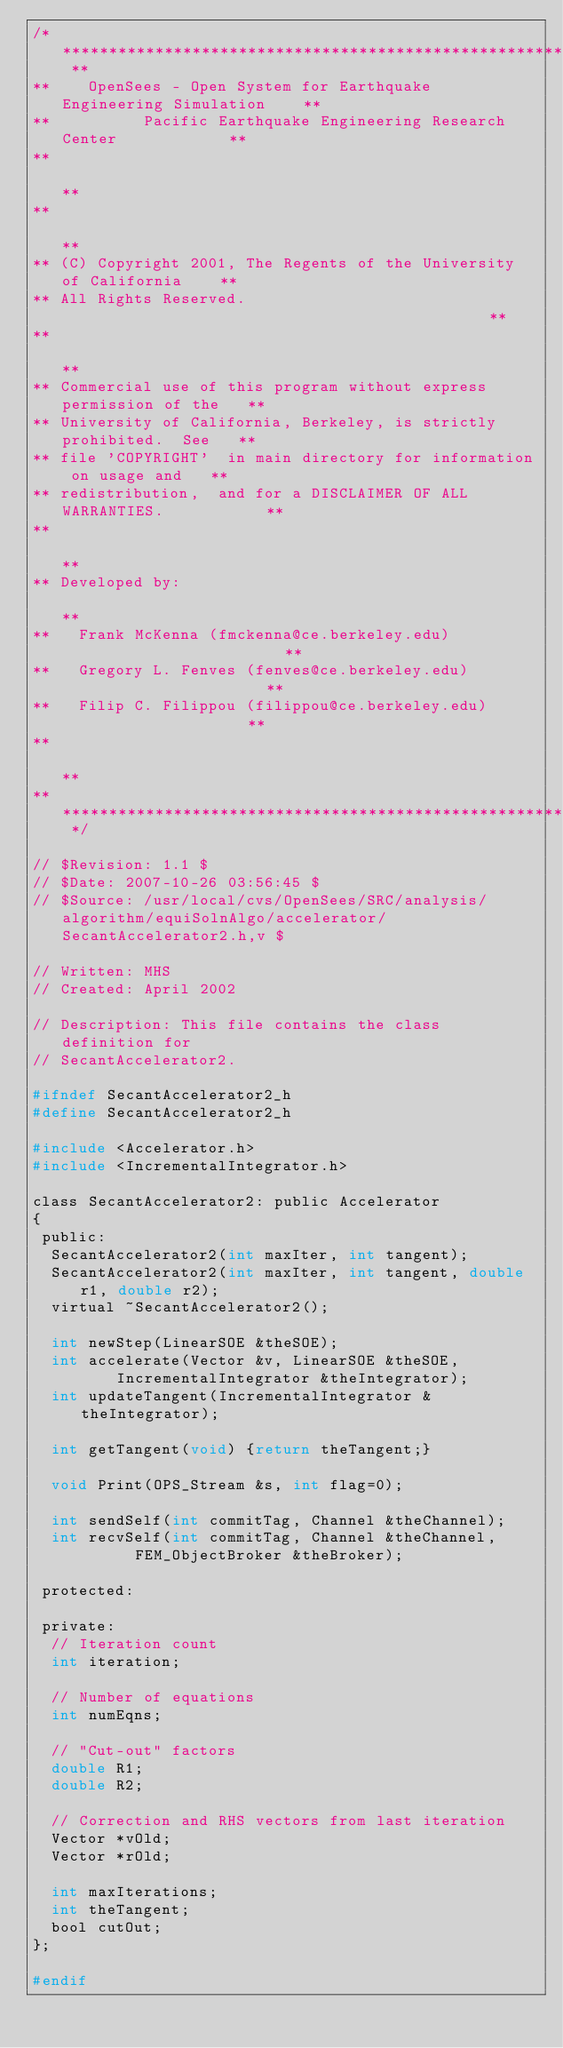Convert code to text. <code><loc_0><loc_0><loc_500><loc_500><_C_>/* ****************************************************************** **
**    OpenSees - Open System for Earthquake Engineering Simulation    **
**          Pacific Earthquake Engineering Research Center            **
**                                                                    **
**                                                                    **
** (C) Copyright 2001, The Regents of the University of California    **
** All Rights Reserved.                                               **
**                                                                    **
** Commercial use of this program without express permission of the   **
** University of California, Berkeley, is strictly prohibited.  See   **
** file 'COPYRIGHT'  in main directory for information on usage and   **
** redistribution,  and for a DISCLAIMER OF ALL WARRANTIES.           **
**                                                                    **
** Developed by:                                                      **
**   Frank McKenna (fmckenna@ce.berkeley.edu)                         **
**   Gregory L. Fenves (fenves@ce.berkeley.edu)                       **
**   Filip C. Filippou (filippou@ce.berkeley.edu)                     **
**                                                                    **
** ****************************************************************** */

// $Revision: 1.1 $
// $Date: 2007-10-26 03:56:45 $
// $Source: /usr/local/cvs/OpenSees/SRC/analysis/algorithm/equiSolnAlgo/accelerator/SecantAccelerator2.h,v $

// Written: MHS
// Created: April 2002

// Description: This file contains the class definition for 
// SecantAccelerator2. 

#ifndef SecantAccelerator2_h
#define SecantAccelerator2_h

#include <Accelerator.h>
#include <IncrementalIntegrator.h>

class SecantAccelerator2: public Accelerator
{
 public:
  SecantAccelerator2(int maxIter, int tangent);
  SecantAccelerator2(int maxIter, int tangent, double r1, double r2);
  virtual ~SecantAccelerator2();
  
  int newStep(LinearSOE &theSOE);
  int accelerate(Vector &v, LinearSOE &theSOE, 
		 IncrementalIntegrator &theIntegrator);
  int updateTangent(IncrementalIntegrator &theIntegrator);
  
  int getTangent(void) {return theTangent;}

  void Print(OPS_Stream &s, int flag=0);
  
  int sendSelf(int commitTag, Channel &theChannel);
  int recvSelf(int commitTag, Channel &theChannel, 
	       FEM_ObjectBroker &theBroker);
  
 protected:
  
 private:
  // Iteration count
  int iteration;
  
  // Number of equations
  int numEqns;
  
  // "Cut-out" factors
  double R1;
  double R2;
  
  // Correction and RHS vectors from last iteration
  Vector *vOld;
  Vector *rOld;
  
  int maxIterations;
  int theTangent;
  bool cutOut;
};

#endif
</code> 